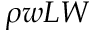Convert formula to latex. <formula><loc_0><loc_0><loc_500><loc_500>\rho w L W</formula> 